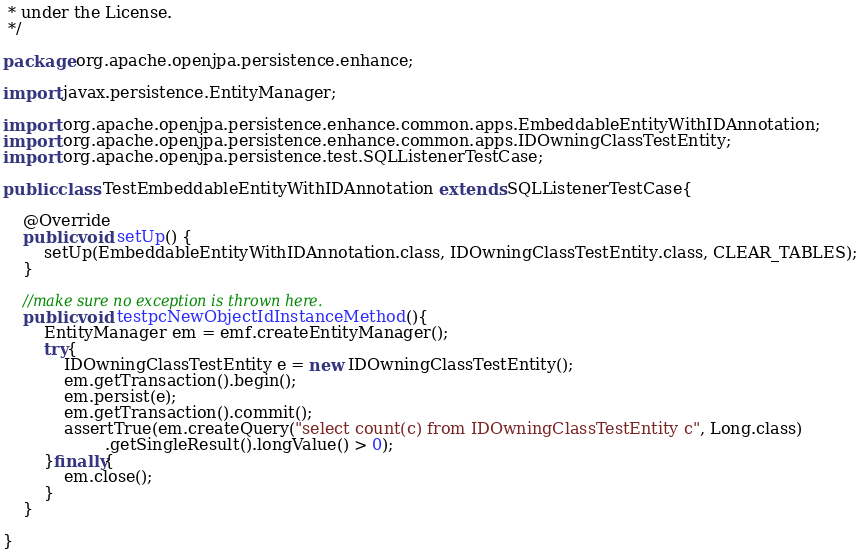<code> <loc_0><loc_0><loc_500><loc_500><_Java_> * under the License.
 */

package org.apache.openjpa.persistence.enhance;

import javax.persistence.EntityManager;

import org.apache.openjpa.persistence.enhance.common.apps.EmbeddableEntityWithIDAnnotation;
import org.apache.openjpa.persistence.enhance.common.apps.IDOwningClassTestEntity;
import org.apache.openjpa.persistence.test.SQLListenerTestCase;

public class TestEmbeddableEntityWithIDAnnotation extends SQLListenerTestCase{

    @Override
    public void setUp() {
        setUp(EmbeddableEntityWithIDAnnotation.class, IDOwningClassTestEntity.class, CLEAR_TABLES);
    }

    //make sure no exception is thrown here.
    public void testpcNewObjectIdInstanceMethod(){
        EntityManager em = emf.createEntityManager();
        try{
            IDOwningClassTestEntity e = new IDOwningClassTestEntity();
            em.getTransaction().begin();
            em.persist(e);
            em.getTransaction().commit();
            assertTrue(em.createQuery("select count(c) from IDOwningClassTestEntity c", Long.class)
                    .getSingleResult().longValue() > 0);
        }finally{
            em.close();
        }
    }

}
</code> 